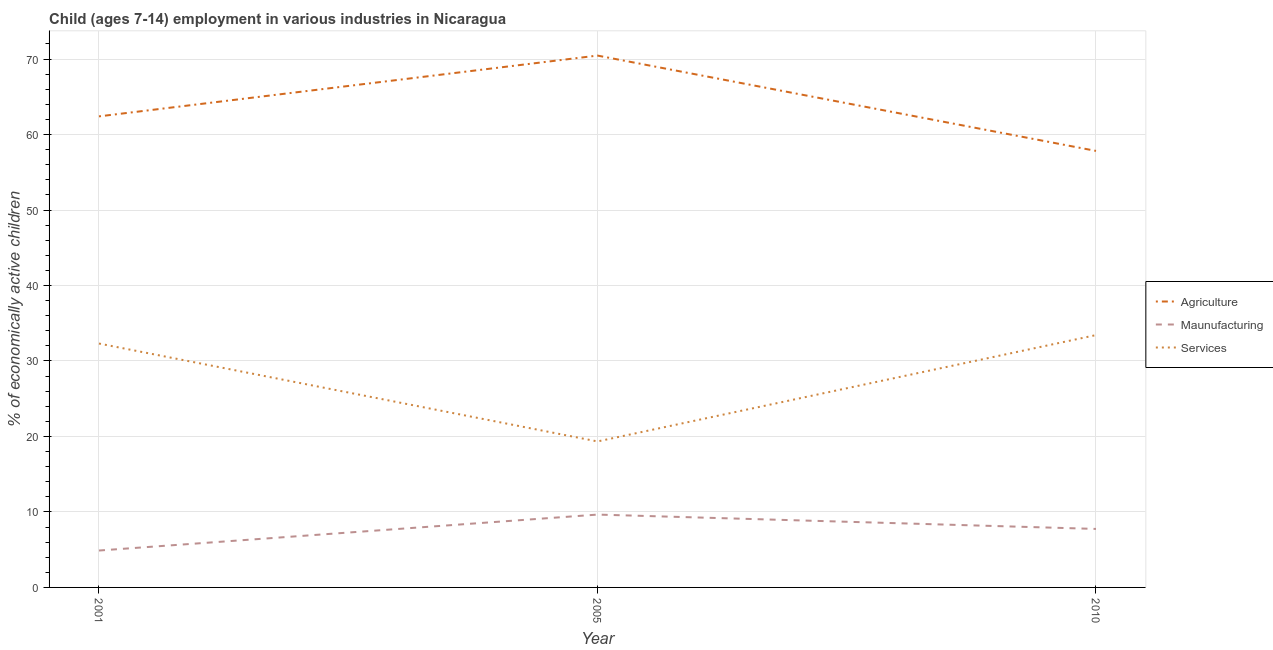What is the percentage of economically active children in manufacturing in 2001?
Keep it short and to the point. 4.89. Across all years, what is the maximum percentage of economically active children in agriculture?
Your response must be concise. 70.46. Across all years, what is the minimum percentage of economically active children in services?
Offer a very short reply. 19.34. In which year was the percentage of economically active children in services maximum?
Provide a succinct answer. 2010. In which year was the percentage of economically active children in manufacturing minimum?
Make the answer very short. 2001. What is the total percentage of economically active children in services in the graph?
Make the answer very short. 85.08. What is the difference between the percentage of economically active children in services in 2005 and that in 2010?
Provide a short and direct response. -14.09. What is the difference between the percentage of economically active children in services in 2010 and the percentage of economically active children in agriculture in 2001?
Your response must be concise. -28.98. What is the average percentage of economically active children in agriculture per year?
Provide a succinct answer. 63.57. In the year 2005, what is the difference between the percentage of economically active children in manufacturing and percentage of economically active children in agriculture?
Give a very brief answer. -60.81. What is the ratio of the percentage of economically active children in agriculture in 2001 to that in 2010?
Provide a succinct answer. 1.08. Is the percentage of economically active children in manufacturing in 2005 less than that in 2010?
Offer a terse response. No. What is the difference between the highest and the second highest percentage of economically active children in manufacturing?
Your answer should be compact. 1.9. What is the difference between the highest and the lowest percentage of economically active children in agriculture?
Make the answer very short. 12.63. Is it the case that in every year, the sum of the percentage of economically active children in agriculture and percentage of economically active children in manufacturing is greater than the percentage of economically active children in services?
Your answer should be very brief. Yes. Is the percentage of economically active children in manufacturing strictly less than the percentage of economically active children in services over the years?
Your answer should be compact. Yes. How many lines are there?
Offer a very short reply. 3. How many years are there in the graph?
Provide a succinct answer. 3. Does the graph contain any zero values?
Offer a very short reply. No. Does the graph contain grids?
Offer a very short reply. Yes. Where does the legend appear in the graph?
Provide a succinct answer. Center right. What is the title of the graph?
Provide a succinct answer. Child (ages 7-14) employment in various industries in Nicaragua. What is the label or title of the Y-axis?
Your answer should be very brief. % of economically active children. What is the % of economically active children of Agriculture in 2001?
Provide a succinct answer. 62.41. What is the % of economically active children of Maunufacturing in 2001?
Your answer should be compact. 4.89. What is the % of economically active children of Services in 2001?
Offer a terse response. 32.31. What is the % of economically active children in Agriculture in 2005?
Your response must be concise. 70.46. What is the % of economically active children in Maunufacturing in 2005?
Ensure brevity in your answer.  9.65. What is the % of economically active children in Services in 2005?
Offer a terse response. 19.34. What is the % of economically active children of Agriculture in 2010?
Your response must be concise. 57.83. What is the % of economically active children in Maunufacturing in 2010?
Your answer should be very brief. 7.75. What is the % of economically active children of Services in 2010?
Make the answer very short. 33.43. Across all years, what is the maximum % of economically active children in Agriculture?
Make the answer very short. 70.46. Across all years, what is the maximum % of economically active children of Maunufacturing?
Keep it short and to the point. 9.65. Across all years, what is the maximum % of economically active children of Services?
Provide a short and direct response. 33.43. Across all years, what is the minimum % of economically active children of Agriculture?
Make the answer very short. 57.83. Across all years, what is the minimum % of economically active children of Maunufacturing?
Make the answer very short. 4.89. Across all years, what is the minimum % of economically active children in Services?
Give a very brief answer. 19.34. What is the total % of economically active children of Agriculture in the graph?
Ensure brevity in your answer.  190.7. What is the total % of economically active children of Maunufacturing in the graph?
Keep it short and to the point. 22.29. What is the total % of economically active children of Services in the graph?
Provide a succinct answer. 85.08. What is the difference between the % of economically active children of Agriculture in 2001 and that in 2005?
Provide a short and direct response. -8.05. What is the difference between the % of economically active children of Maunufacturing in 2001 and that in 2005?
Your response must be concise. -4.76. What is the difference between the % of economically active children of Services in 2001 and that in 2005?
Give a very brief answer. 12.97. What is the difference between the % of economically active children of Agriculture in 2001 and that in 2010?
Ensure brevity in your answer.  4.58. What is the difference between the % of economically active children of Maunufacturing in 2001 and that in 2010?
Provide a succinct answer. -2.86. What is the difference between the % of economically active children in Services in 2001 and that in 2010?
Give a very brief answer. -1.12. What is the difference between the % of economically active children of Agriculture in 2005 and that in 2010?
Offer a terse response. 12.63. What is the difference between the % of economically active children in Maunufacturing in 2005 and that in 2010?
Your answer should be very brief. 1.9. What is the difference between the % of economically active children of Services in 2005 and that in 2010?
Ensure brevity in your answer.  -14.09. What is the difference between the % of economically active children of Agriculture in 2001 and the % of economically active children of Maunufacturing in 2005?
Provide a short and direct response. 52.76. What is the difference between the % of economically active children of Agriculture in 2001 and the % of economically active children of Services in 2005?
Give a very brief answer. 43.07. What is the difference between the % of economically active children of Maunufacturing in 2001 and the % of economically active children of Services in 2005?
Provide a short and direct response. -14.45. What is the difference between the % of economically active children in Agriculture in 2001 and the % of economically active children in Maunufacturing in 2010?
Keep it short and to the point. 54.66. What is the difference between the % of economically active children in Agriculture in 2001 and the % of economically active children in Services in 2010?
Make the answer very short. 28.98. What is the difference between the % of economically active children in Maunufacturing in 2001 and the % of economically active children in Services in 2010?
Your answer should be very brief. -28.54. What is the difference between the % of economically active children of Agriculture in 2005 and the % of economically active children of Maunufacturing in 2010?
Keep it short and to the point. 62.71. What is the difference between the % of economically active children of Agriculture in 2005 and the % of economically active children of Services in 2010?
Keep it short and to the point. 37.03. What is the difference between the % of economically active children in Maunufacturing in 2005 and the % of economically active children in Services in 2010?
Your answer should be very brief. -23.78. What is the average % of economically active children of Agriculture per year?
Make the answer very short. 63.57. What is the average % of economically active children of Maunufacturing per year?
Give a very brief answer. 7.43. What is the average % of economically active children in Services per year?
Your answer should be compact. 28.36. In the year 2001, what is the difference between the % of economically active children of Agriculture and % of economically active children of Maunufacturing?
Make the answer very short. 57.52. In the year 2001, what is the difference between the % of economically active children of Agriculture and % of economically active children of Services?
Provide a succinct answer. 30.09. In the year 2001, what is the difference between the % of economically active children of Maunufacturing and % of economically active children of Services?
Give a very brief answer. -27.42. In the year 2005, what is the difference between the % of economically active children in Agriculture and % of economically active children in Maunufacturing?
Provide a succinct answer. 60.81. In the year 2005, what is the difference between the % of economically active children in Agriculture and % of economically active children in Services?
Offer a very short reply. 51.12. In the year 2005, what is the difference between the % of economically active children of Maunufacturing and % of economically active children of Services?
Provide a succinct answer. -9.69. In the year 2010, what is the difference between the % of economically active children in Agriculture and % of economically active children in Maunufacturing?
Offer a terse response. 50.08. In the year 2010, what is the difference between the % of economically active children of Agriculture and % of economically active children of Services?
Make the answer very short. 24.4. In the year 2010, what is the difference between the % of economically active children in Maunufacturing and % of economically active children in Services?
Give a very brief answer. -25.68. What is the ratio of the % of economically active children of Agriculture in 2001 to that in 2005?
Your answer should be compact. 0.89. What is the ratio of the % of economically active children in Maunufacturing in 2001 to that in 2005?
Make the answer very short. 0.51. What is the ratio of the % of economically active children of Services in 2001 to that in 2005?
Offer a terse response. 1.67. What is the ratio of the % of economically active children of Agriculture in 2001 to that in 2010?
Provide a succinct answer. 1.08. What is the ratio of the % of economically active children in Maunufacturing in 2001 to that in 2010?
Offer a very short reply. 0.63. What is the ratio of the % of economically active children of Services in 2001 to that in 2010?
Your answer should be compact. 0.97. What is the ratio of the % of economically active children of Agriculture in 2005 to that in 2010?
Keep it short and to the point. 1.22. What is the ratio of the % of economically active children in Maunufacturing in 2005 to that in 2010?
Offer a very short reply. 1.25. What is the ratio of the % of economically active children of Services in 2005 to that in 2010?
Ensure brevity in your answer.  0.58. What is the difference between the highest and the second highest % of economically active children in Agriculture?
Your answer should be very brief. 8.05. What is the difference between the highest and the second highest % of economically active children of Services?
Provide a short and direct response. 1.12. What is the difference between the highest and the lowest % of economically active children of Agriculture?
Your answer should be compact. 12.63. What is the difference between the highest and the lowest % of economically active children of Maunufacturing?
Your answer should be compact. 4.76. What is the difference between the highest and the lowest % of economically active children in Services?
Keep it short and to the point. 14.09. 